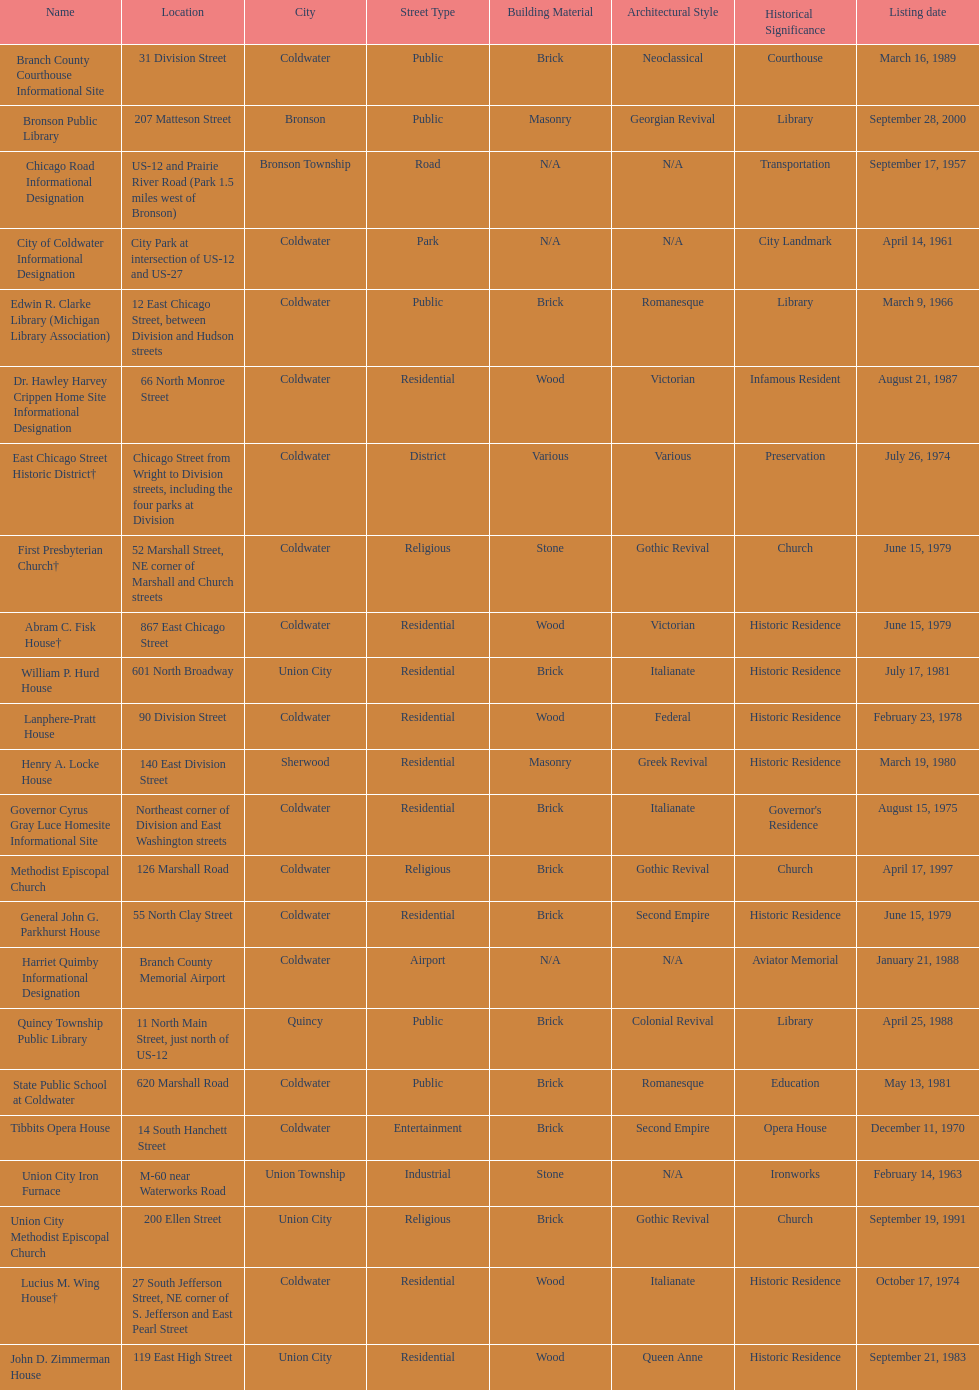How many sites are in coldwater? 15. 